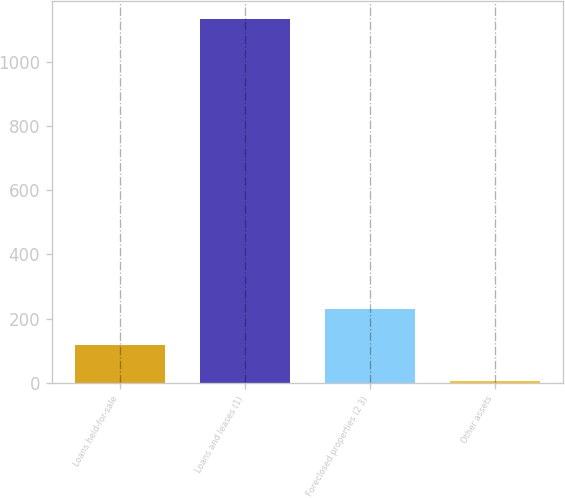Convert chart to OTSL. <chart><loc_0><loc_0><loc_500><loc_500><bar_chart><fcel>Loans held-for-sale<fcel>Loans and leases (1)<fcel>Foreclosed properties (2 3)<fcel>Other assets<nl><fcel>118.6<fcel>1132<fcel>231.2<fcel>6<nl></chart> 